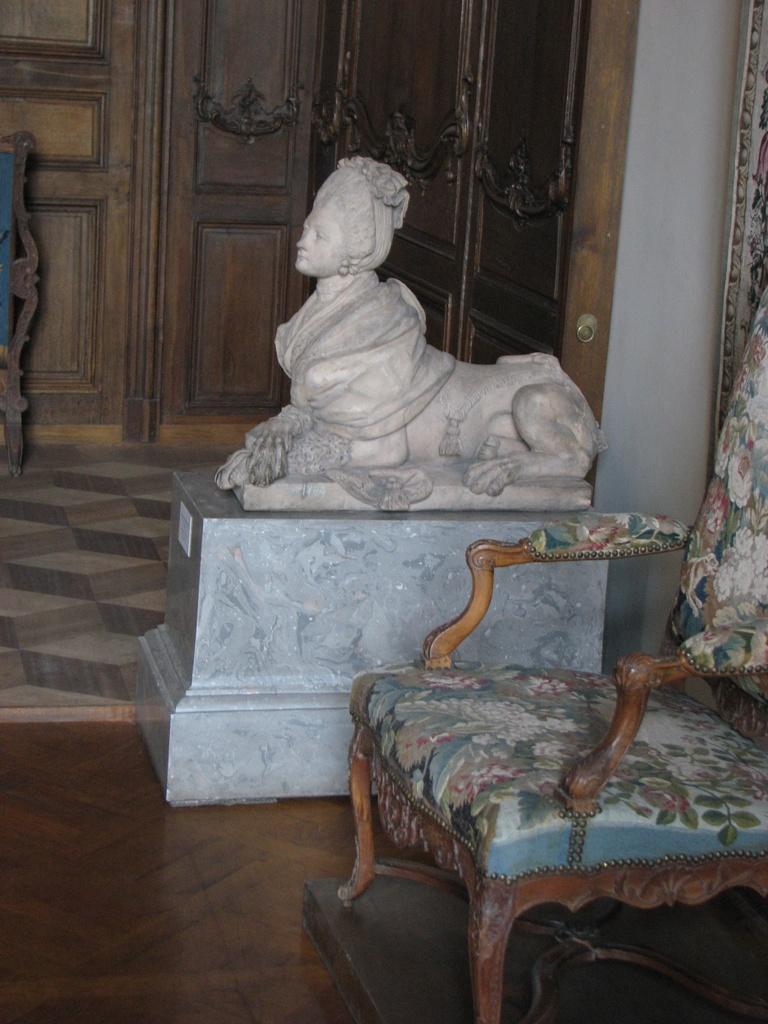Please provide a concise description of this image. In this image we can see a chair, statue and a wooden door in the background. 